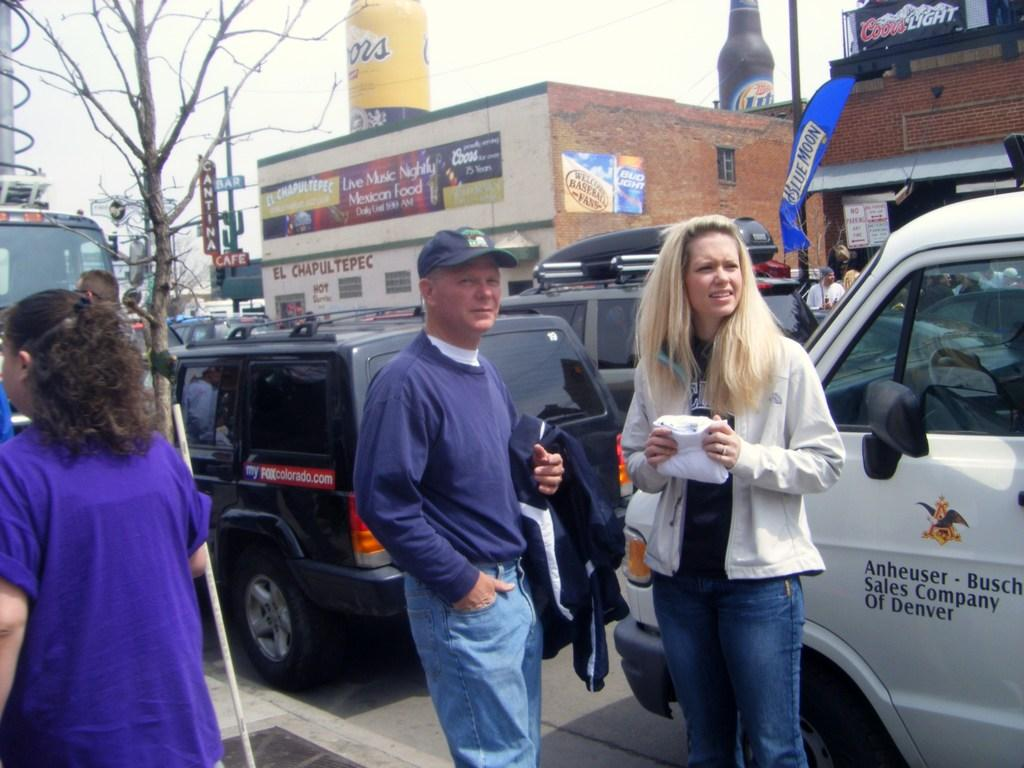Provide a one-sentence caption for the provided image. A man and woman stand on the sidewalk beside an Anheuser and Busch sales company truck. 